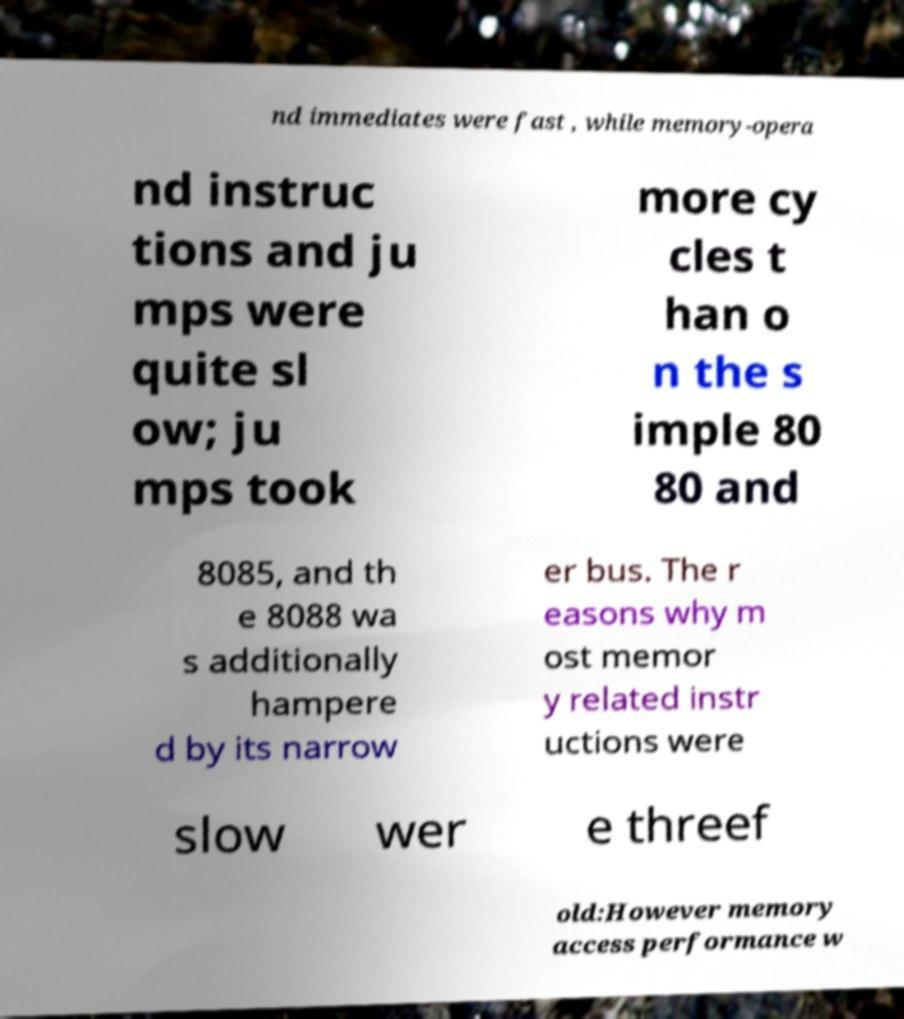For documentation purposes, I need the text within this image transcribed. Could you provide that? nd immediates were fast , while memory-opera nd instruc tions and ju mps were quite sl ow; ju mps took more cy cles t han o n the s imple 80 80 and 8085, and th e 8088 wa s additionally hampere d by its narrow er bus. The r easons why m ost memor y related instr uctions were slow wer e threef old:However memory access performance w 